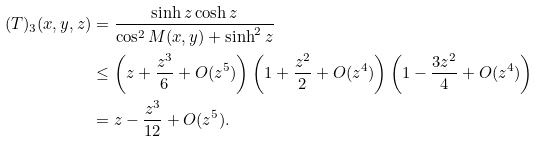Convert formula to latex. <formula><loc_0><loc_0><loc_500><loc_500>( T ) _ { 3 } ( x , y , z ) & = \frac { \sinh z \cosh z } { \cos ^ { 2 } M ( x , y ) + \sinh ^ { 2 } z } \\ & \leq \left ( z + \frac { z ^ { 3 } } { 6 } + O ( z ^ { 5 } ) \right ) \left ( 1 + \frac { z ^ { 2 } } { 2 } + O ( z ^ { 4 } ) \right ) \left ( 1 - \frac { 3 z ^ { 2 } } { 4 } + O ( z ^ { 4 } ) \right ) \\ & = z - \frac { z ^ { 3 } } { 1 2 } + O ( z ^ { 5 } ) .</formula> 